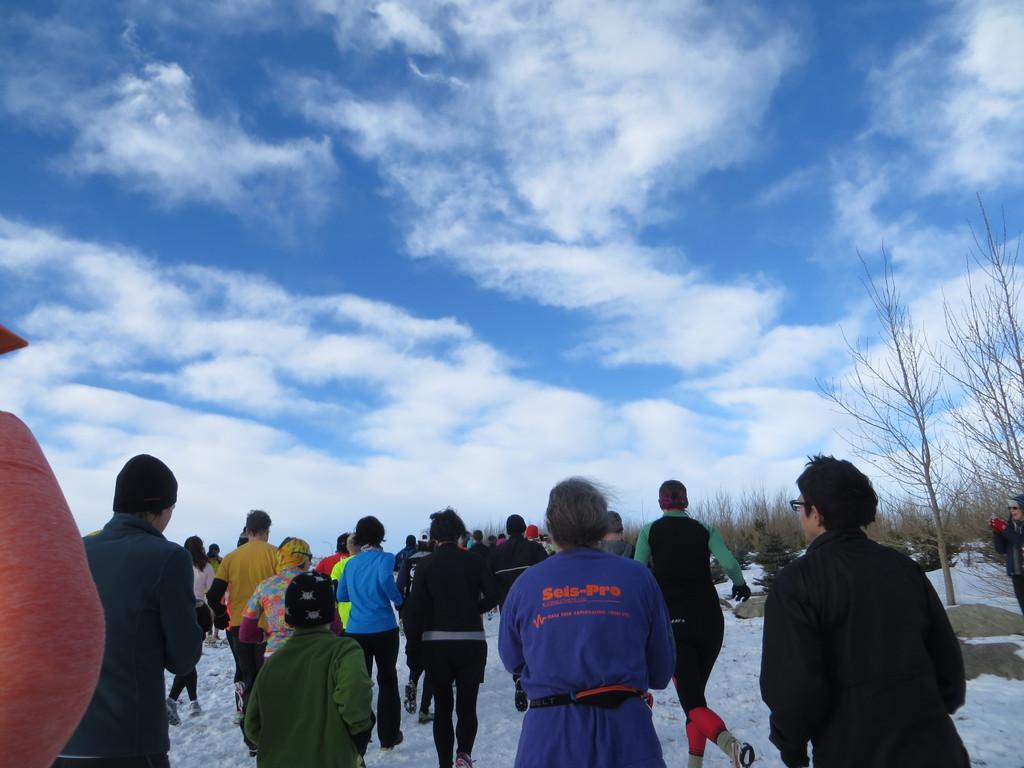Describe this image in one or two sentences. In this picture I can observe some people walking on the snow. There are men, women and children in this picture. In the background I can observe clouds in the sky. 